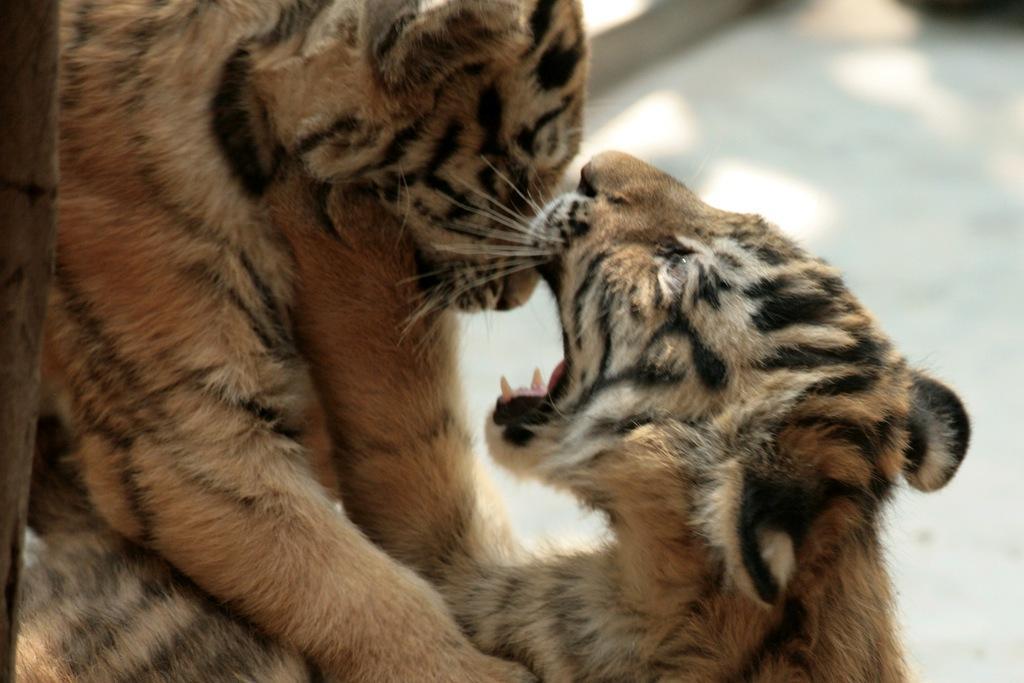Describe this image in one or two sentences. In this image we can see there are animals on the floor. And at the side there is a stick. 